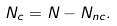<formula> <loc_0><loc_0><loc_500><loc_500>N _ { c } = N - N _ { n c } .</formula> 